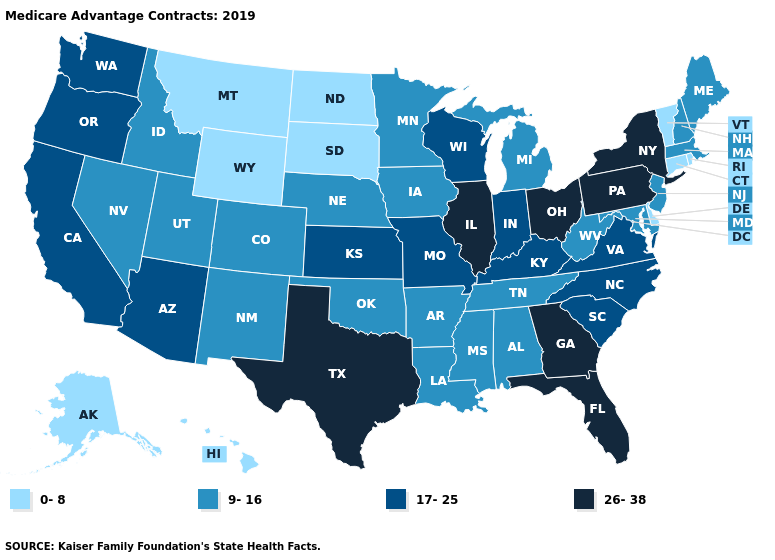What is the value of New Hampshire?
Answer briefly. 9-16. How many symbols are there in the legend?
Short answer required. 4. What is the value of Mississippi?
Answer briefly. 9-16. Name the states that have a value in the range 9-16?
Short answer required. Alabama, Arkansas, Colorado, Idaho, Iowa, Louisiana, Maine, Maryland, Massachusetts, Michigan, Minnesota, Mississippi, Nebraska, Nevada, New Hampshire, New Jersey, New Mexico, Oklahoma, Tennessee, Utah, West Virginia. What is the highest value in the USA?
Concise answer only. 26-38. What is the value of Oklahoma?
Answer briefly. 9-16. Does Vermont have the highest value in the USA?
Write a very short answer. No. Which states have the highest value in the USA?
Answer briefly. Florida, Georgia, Illinois, New York, Ohio, Pennsylvania, Texas. What is the value of Illinois?
Keep it brief. 26-38. What is the lowest value in states that border Arizona?
Short answer required. 9-16. Does the map have missing data?
Give a very brief answer. No. Which states hav the highest value in the MidWest?
Keep it brief. Illinois, Ohio. Does New York have the highest value in the Northeast?
Keep it brief. Yes. What is the value of North Dakota?
Keep it brief. 0-8. What is the value of New Mexico?
Answer briefly. 9-16. 